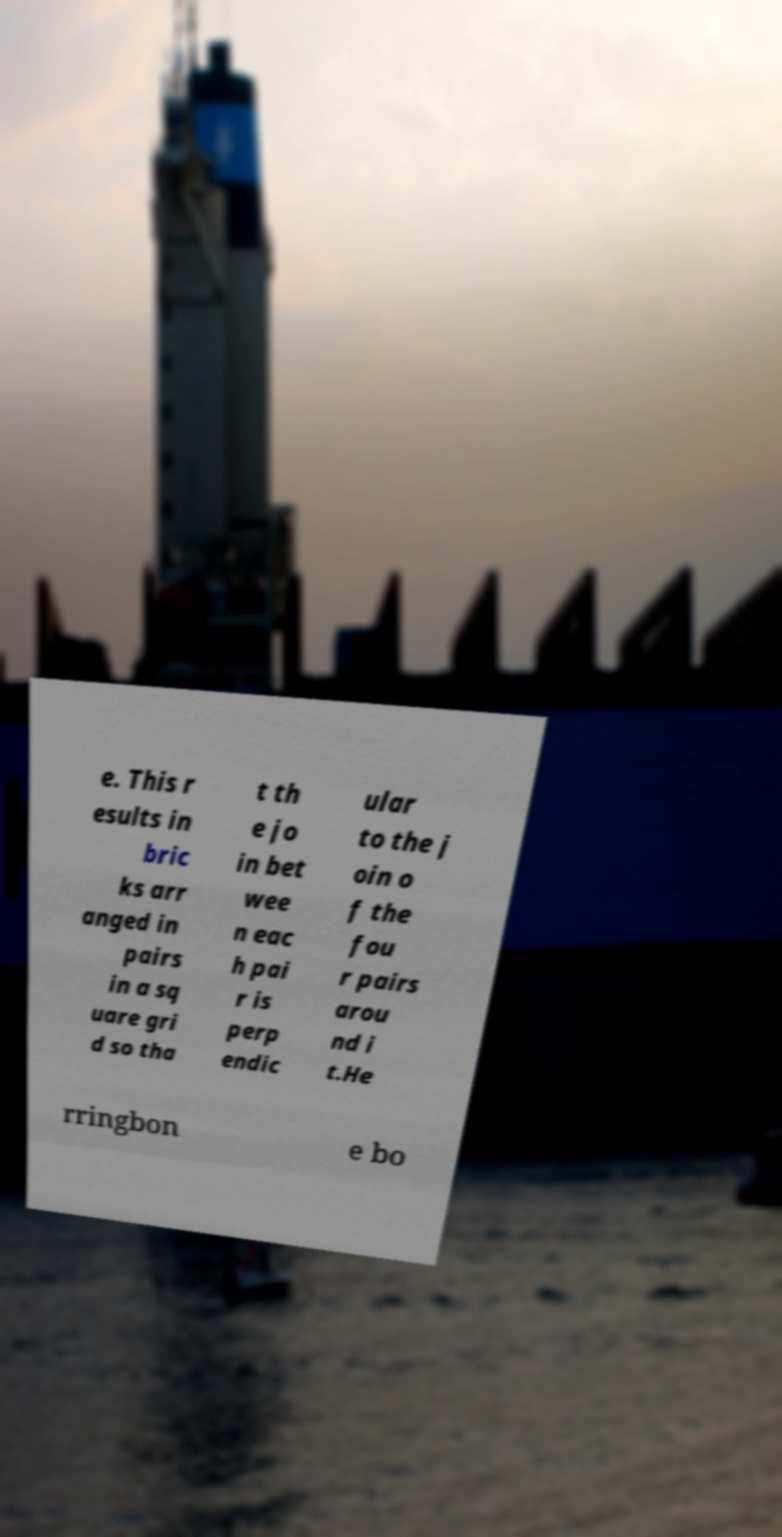Can you read and provide the text displayed in the image?This photo seems to have some interesting text. Can you extract and type it out for me? e. This r esults in bric ks arr anged in pairs in a sq uare gri d so tha t th e jo in bet wee n eac h pai r is perp endic ular to the j oin o f the fou r pairs arou nd i t.He rringbon e bo 